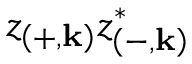Convert formula to latex. <formula><loc_0><loc_0><loc_500><loc_500>z _ { \left ( + , k \right ) } z _ { \left ( - , k \right ) } ^ { * }</formula> 